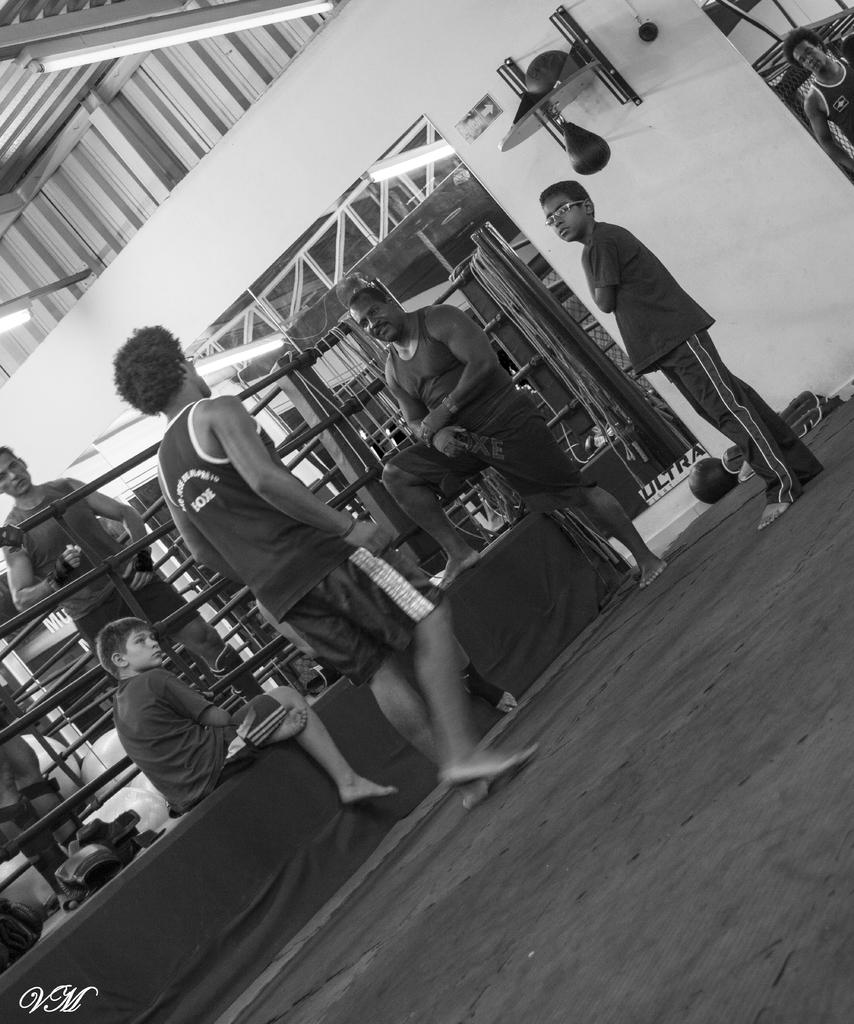What are the people in the image doing? The people in the image are standing in a ring. What can be seen behind the people in the image? There is a wall visible at the back side of the image. What type of furniture can be seen in the image? There is no furniture visible in the image; it only shows people standing in a ring and a wall in the background. 